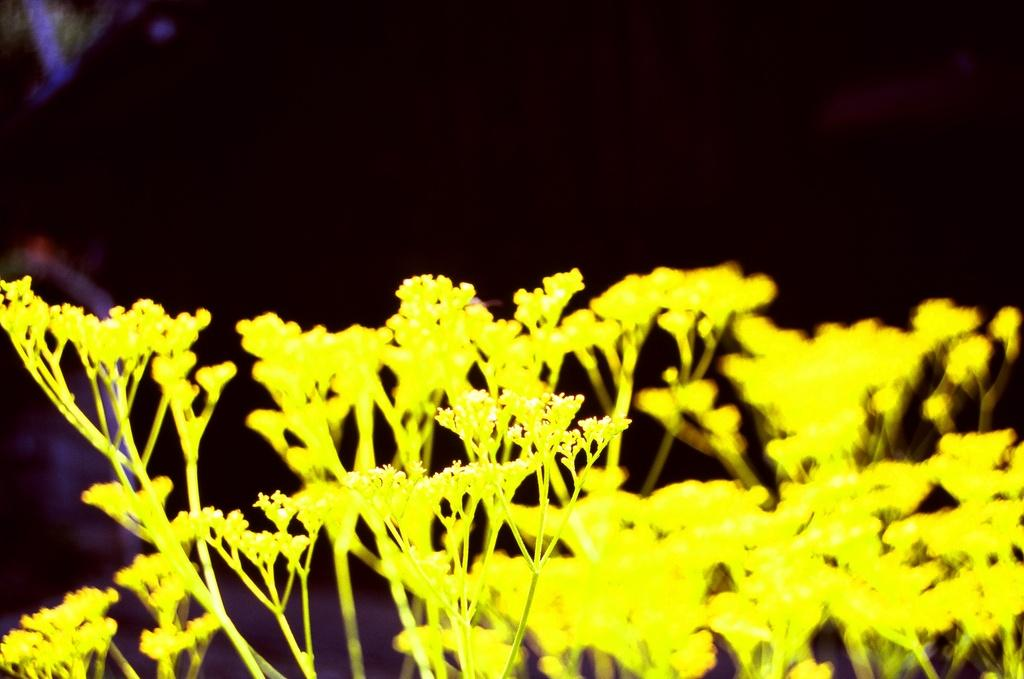What type of living organisms can be seen in the image? Plants can be seen in the image. What specific feature of the plants is visible in the image? The plants have flowers. How many apples are hanging from the plants in the image? There are no apples present in the image; it features plants with flowers. What type of shirt is being worn by the plant in the image? There is no shirt present in the image, as plants do not wear clothing. 